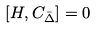Convert formula to latex. <formula><loc_0><loc_0><loc_500><loc_500>[ H , C _ { \bar { \Delta } } ] = 0</formula> 